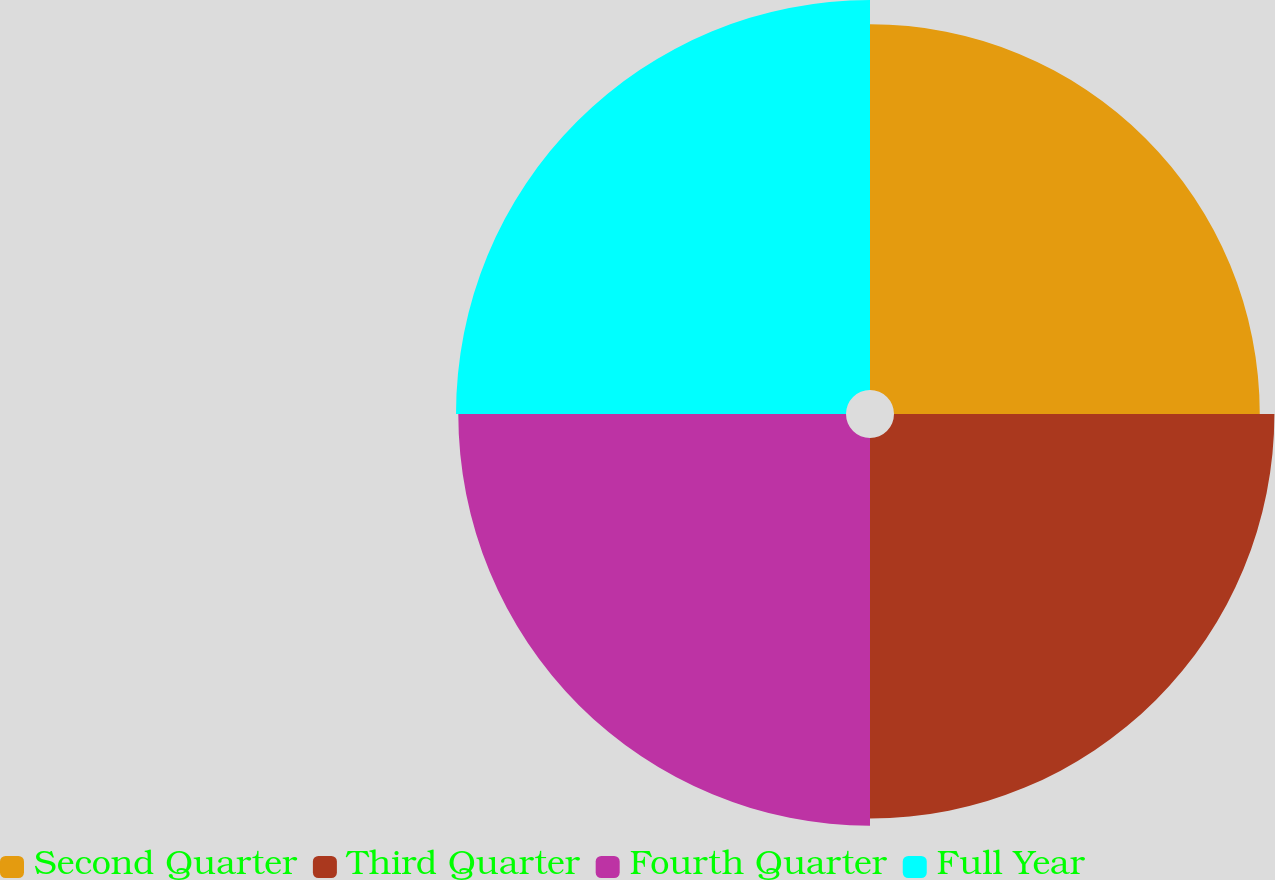Convert chart. <chart><loc_0><loc_0><loc_500><loc_500><pie_chart><fcel>Second Quarter<fcel>Third Quarter<fcel>Fourth Quarter<fcel>Full Year<nl><fcel>24.0%<fcel>24.96%<fcel>25.44%<fcel>25.59%<nl></chart> 